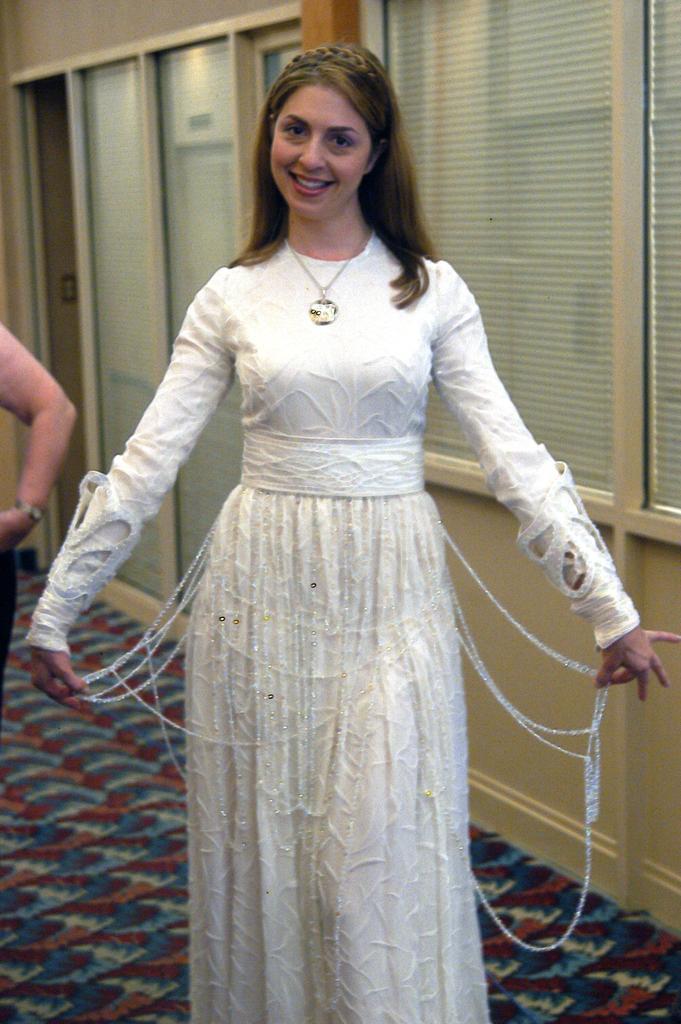Can you describe this image briefly? In the center of the image, we can see a lady smiling and standing and wearing costume. In the background, there are doors and we can see a person standing. At the bottom, there is floor. 